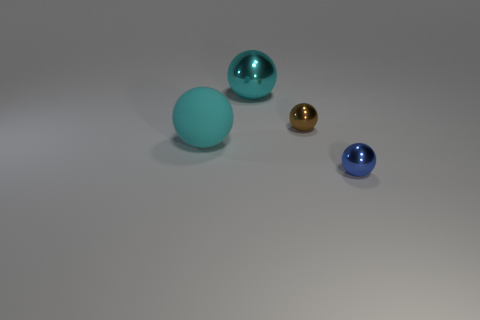Subtract all yellow cubes. How many cyan spheres are left? 2 Subtract all blue balls. How many balls are left? 3 Subtract 2 spheres. How many spheres are left? 2 Subtract all large metal spheres. How many spheres are left? 3 Add 1 cyan objects. How many objects exist? 5 Subtract all green spheres. Subtract all gray cylinders. How many spheres are left? 4 Subtract all big red metallic spheres. Subtract all matte balls. How many objects are left? 3 Add 2 cyan rubber spheres. How many cyan rubber spheres are left? 3 Add 2 brown things. How many brown things exist? 3 Subtract 0 blue blocks. How many objects are left? 4 